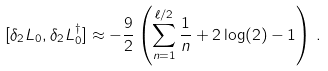Convert formula to latex. <formula><loc_0><loc_0><loc_500><loc_500>& [ \delta _ { 2 } \L L _ { 0 } , \delta _ { 2 } \L L _ { 0 } ^ { \dagger } ] \approx - \frac { 9 } { 2 } \left ( \sum _ { n = 1 } ^ { \ell / 2 } \frac { 1 } { n } + 2 \log ( 2 ) - 1 \right ) \, .</formula> 